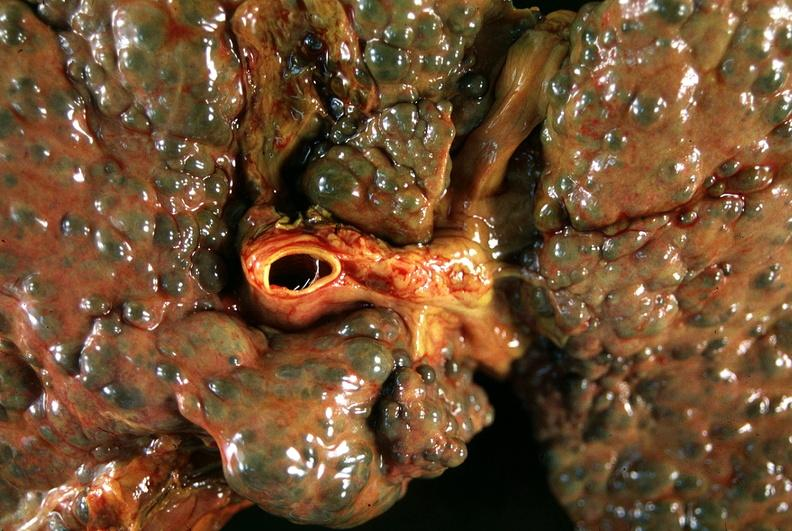what is present?
Answer the question using a single word or phrase. Hepatobiliary 